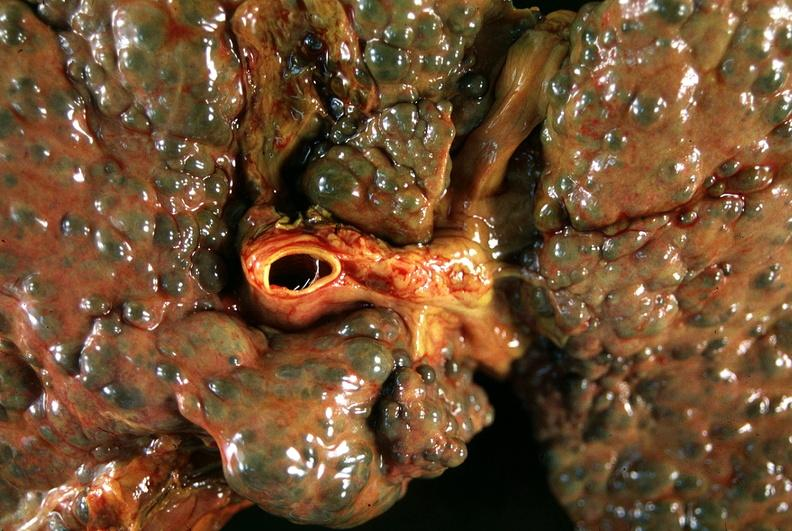what is present?
Answer the question using a single word or phrase. Hepatobiliary 